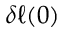<formula> <loc_0><loc_0><loc_500><loc_500>\delta \ell ( 0 )</formula> 